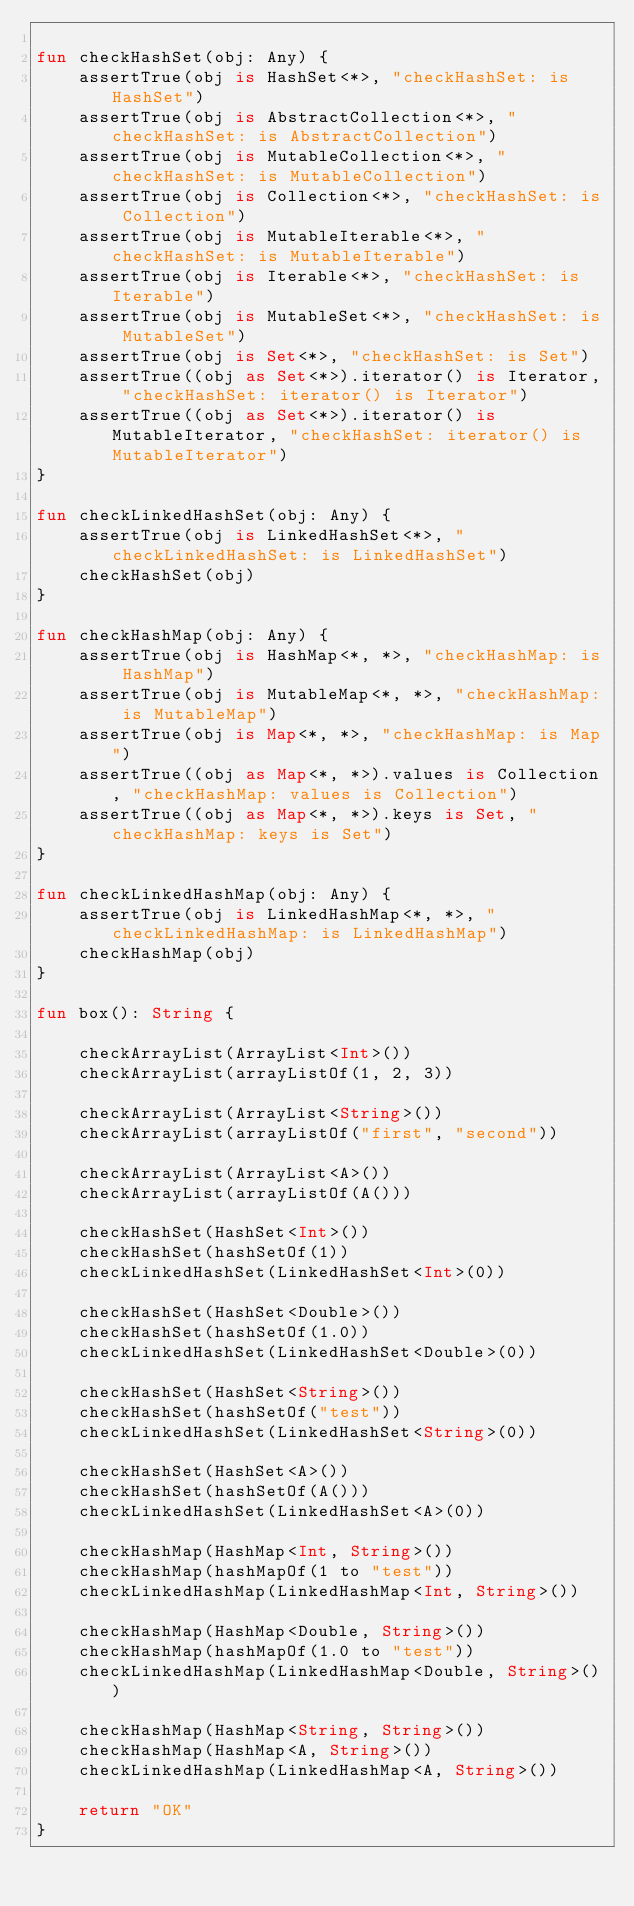Convert code to text. <code><loc_0><loc_0><loc_500><loc_500><_Kotlin_>
fun checkHashSet(obj: Any) {
    assertTrue(obj is HashSet<*>, "checkHashSet: is HashSet")
    assertTrue(obj is AbstractCollection<*>, "checkHashSet: is AbstractCollection")
    assertTrue(obj is MutableCollection<*>, "checkHashSet: is MutableCollection")
    assertTrue(obj is Collection<*>, "checkHashSet: is Collection")
    assertTrue(obj is MutableIterable<*>, "checkHashSet: is MutableIterable")
    assertTrue(obj is Iterable<*>, "checkHashSet: is Iterable")
    assertTrue(obj is MutableSet<*>, "checkHashSet: is MutableSet")
    assertTrue(obj is Set<*>, "checkHashSet: is Set")
    assertTrue((obj as Set<*>).iterator() is Iterator, "checkHashSet: iterator() is Iterator")
    assertTrue((obj as Set<*>).iterator() is MutableIterator, "checkHashSet: iterator() is MutableIterator")
}

fun checkLinkedHashSet(obj: Any) {
    assertTrue(obj is LinkedHashSet<*>, "checkLinkedHashSet: is LinkedHashSet")
    checkHashSet(obj)
}

fun checkHashMap(obj: Any) {
    assertTrue(obj is HashMap<*, *>, "checkHashMap: is HashMap")
    assertTrue(obj is MutableMap<*, *>, "checkHashMap: is MutableMap")
    assertTrue(obj is Map<*, *>, "checkHashMap: is Map")
    assertTrue((obj as Map<*, *>).values is Collection, "checkHashMap: values is Collection")
    assertTrue((obj as Map<*, *>).keys is Set, "checkHashMap: keys is Set")
}

fun checkLinkedHashMap(obj: Any) {
    assertTrue(obj is LinkedHashMap<*, *>, "checkLinkedHashMap: is LinkedHashMap")
    checkHashMap(obj)
}

fun box(): String {

    checkArrayList(ArrayList<Int>())
    checkArrayList(arrayListOf(1, 2, 3))

    checkArrayList(ArrayList<String>())
    checkArrayList(arrayListOf("first", "second"))

    checkArrayList(ArrayList<A>())
    checkArrayList(arrayListOf(A()))

    checkHashSet(HashSet<Int>())
    checkHashSet(hashSetOf(1))
    checkLinkedHashSet(LinkedHashSet<Int>(0))

    checkHashSet(HashSet<Double>())
    checkHashSet(hashSetOf(1.0))
    checkLinkedHashSet(LinkedHashSet<Double>(0))

    checkHashSet(HashSet<String>())
    checkHashSet(hashSetOf("test"))
    checkLinkedHashSet(LinkedHashSet<String>(0))

    checkHashSet(HashSet<A>())
    checkHashSet(hashSetOf(A()))
    checkLinkedHashSet(LinkedHashSet<A>(0))

    checkHashMap(HashMap<Int, String>())
    checkHashMap(hashMapOf(1 to "test"))
    checkLinkedHashMap(LinkedHashMap<Int, String>())

    checkHashMap(HashMap<Double, String>())
    checkHashMap(hashMapOf(1.0 to "test"))
    checkLinkedHashMap(LinkedHashMap<Double, String>())

    checkHashMap(HashMap<String, String>())
    checkHashMap(HashMap<A, String>())
    checkLinkedHashMap(LinkedHashMap<A, String>())

    return "OK"
}</code> 